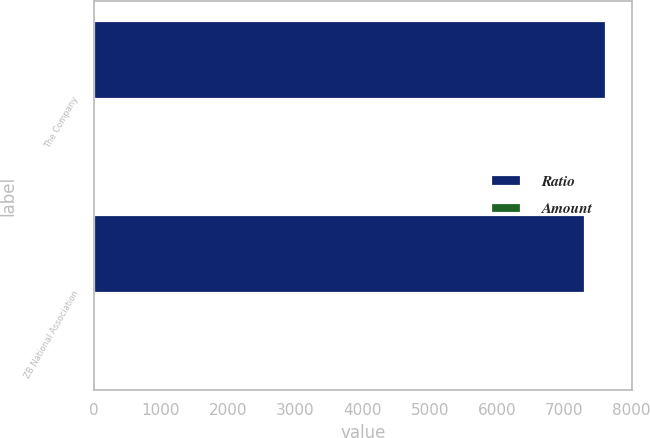<chart> <loc_0><loc_0><loc_500><loc_500><stacked_bar_chart><ecel><fcel>The Company<fcel>ZB National Association<nl><fcel>Ratio<fcel>7628<fcel>7306<nl><fcel>Amount<fcel>14.8<fcel>14.2<nl></chart> 